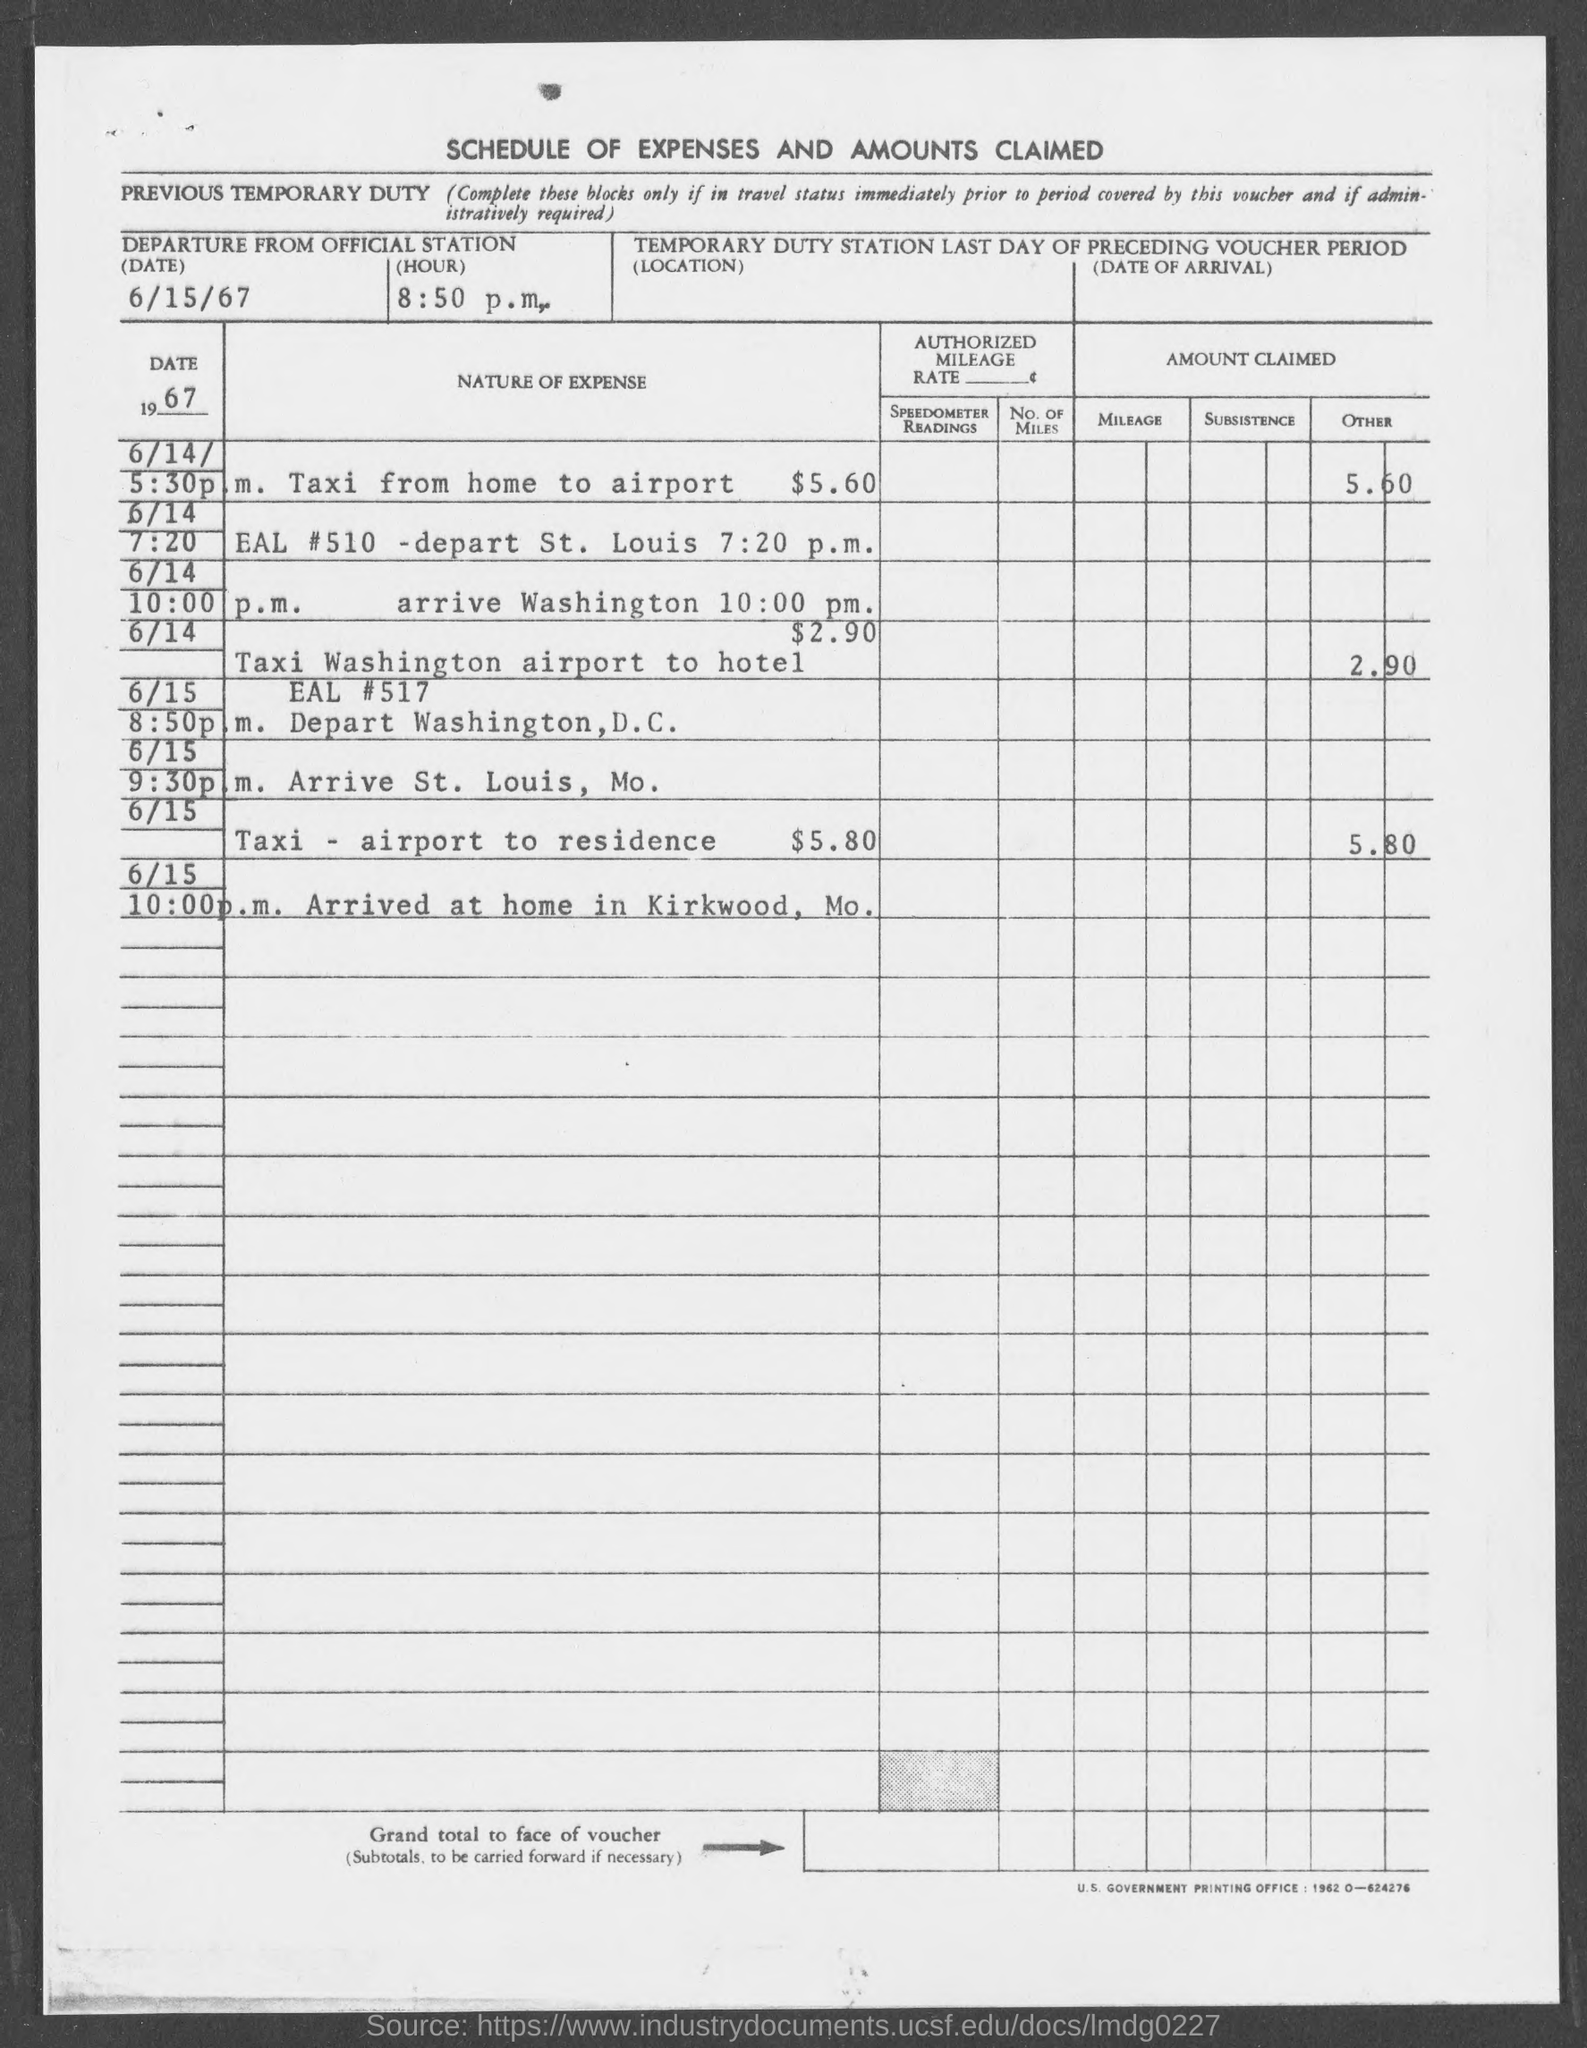Give some essential details in this illustration. The departure time mentioned in the given form is 8:50 p.m. The departure date mentioned in the given form is June 15, 1967. 